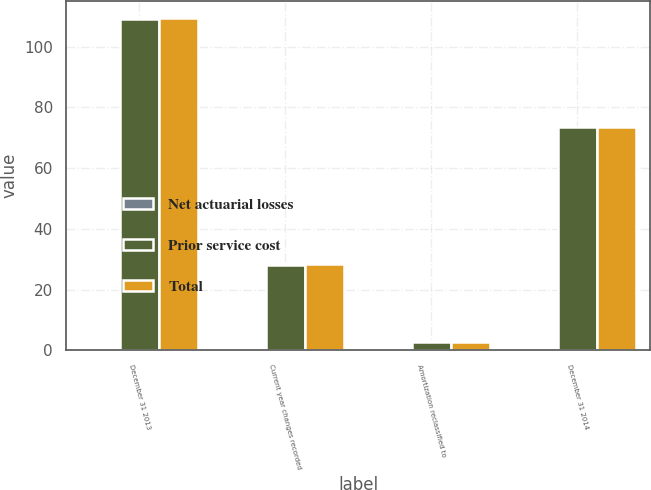<chart> <loc_0><loc_0><loc_500><loc_500><stacked_bar_chart><ecel><fcel>December 31 2013<fcel>Current year changes recorded<fcel>Amortization reclassified to<fcel>December 31 2014<nl><fcel>Net actuarial losses<fcel>0.3<fcel>0.3<fcel>0.1<fcel>0.1<nl><fcel>Prior service cost<fcel>109.2<fcel>28.1<fcel>2.8<fcel>73.5<nl><fcel>Total<fcel>109.5<fcel>28.4<fcel>2.9<fcel>73.4<nl></chart> 